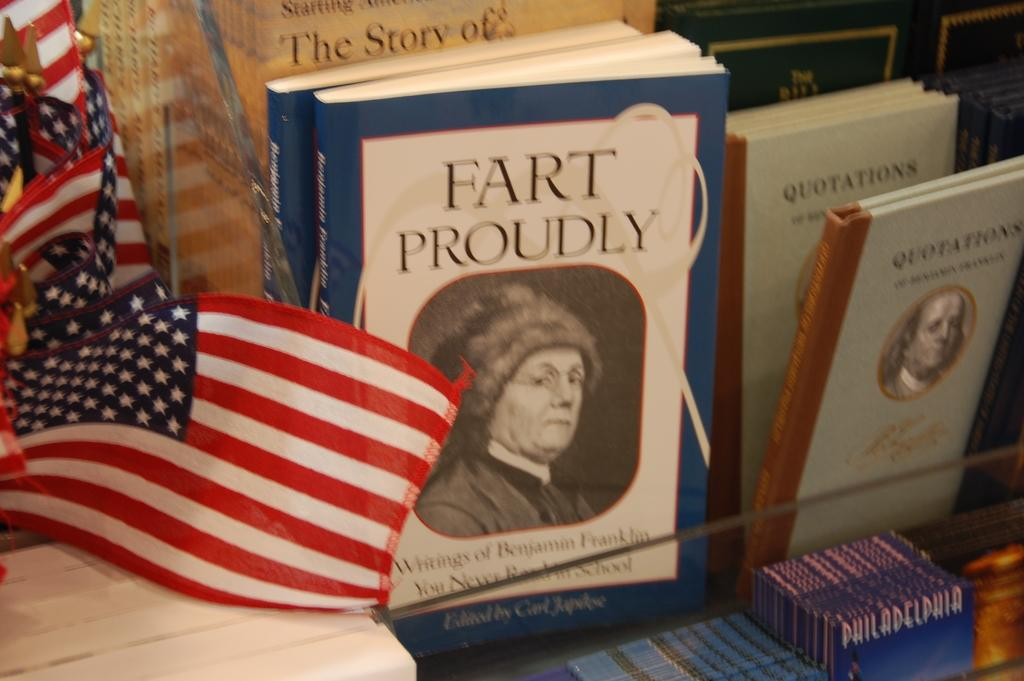<image>
Offer a succinct explanation of the picture presented. A book titled Fart Proudly sitting next to an American Flag. 